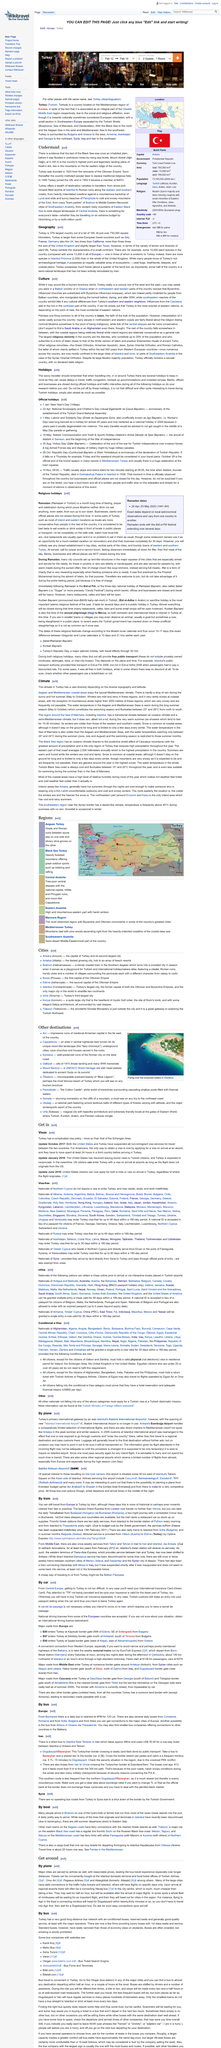Highlight a few significant elements in this photo. The duration of the direct bus journey from Tehran to Istanbul is approximately 48 hours. Atatüruk International Airport was the primary international gateway for Turkey by plane before it was replaced by the new Istanbul Airport. Yes, it is possible to reach Bodrum by boat, as many individuals arrive in the city via hydro-foils or ferries. The subheading of this Wikipedia article is 'By car.' Oludeniz, known as perhaps the most renowned beach in Turkey, is a site that is frequently featured in tourism brochures. 